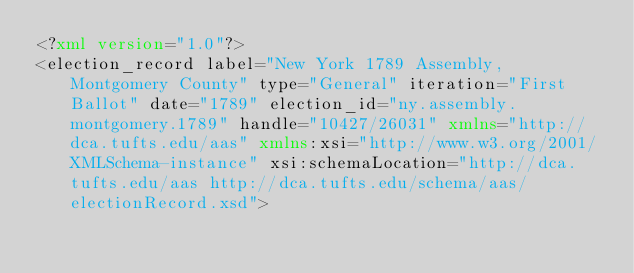Convert code to text. <code><loc_0><loc_0><loc_500><loc_500><_XML_><?xml version="1.0"?>
<election_record label="New York 1789 Assembly, Montgomery County" type="General" iteration="First Ballot" date="1789" election_id="ny.assembly.montgomery.1789" handle="10427/26031" xmlns="http://dca.tufts.edu/aas" xmlns:xsi="http://www.w3.org/2001/XMLSchema-instance" xsi:schemaLocation="http://dca.tufts.edu/aas http://dca.tufts.edu/schema/aas/electionRecord.xsd"></code> 